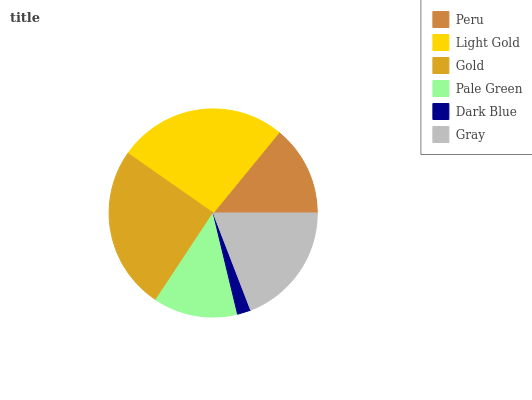Is Dark Blue the minimum?
Answer yes or no. Yes. Is Light Gold the maximum?
Answer yes or no. Yes. Is Gold the minimum?
Answer yes or no. No. Is Gold the maximum?
Answer yes or no. No. Is Light Gold greater than Gold?
Answer yes or no. Yes. Is Gold less than Light Gold?
Answer yes or no. Yes. Is Gold greater than Light Gold?
Answer yes or no. No. Is Light Gold less than Gold?
Answer yes or no. No. Is Gray the high median?
Answer yes or no. Yes. Is Peru the low median?
Answer yes or no. Yes. Is Peru the high median?
Answer yes or no. No. Is Gold the low median?
Answer yes or no. No. 